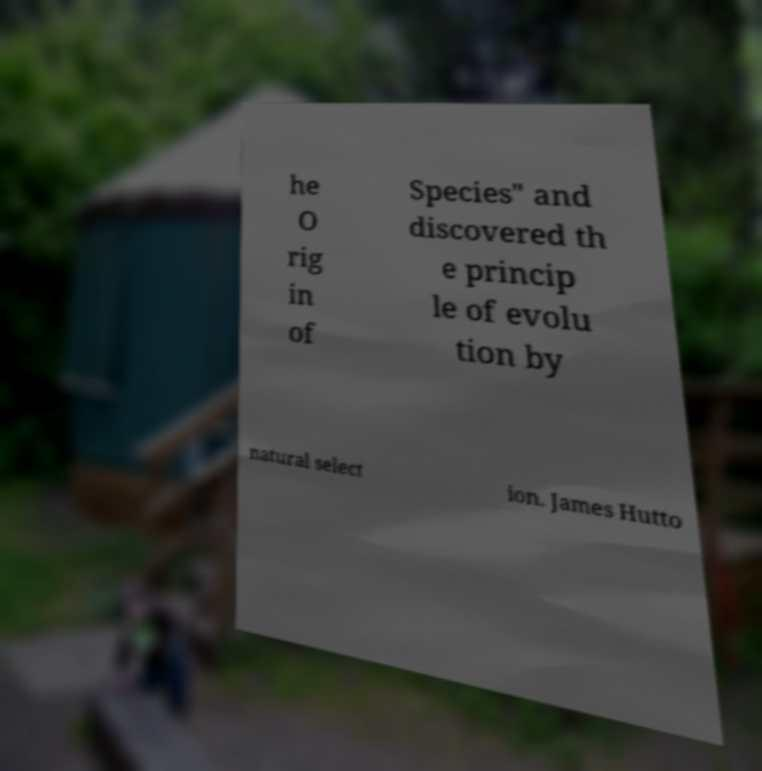Can you accurately transcribe the text from the provided image for me? he O rig in of Species" and discovered th e princip le of evolu tion by natural select ion. James Hutto 